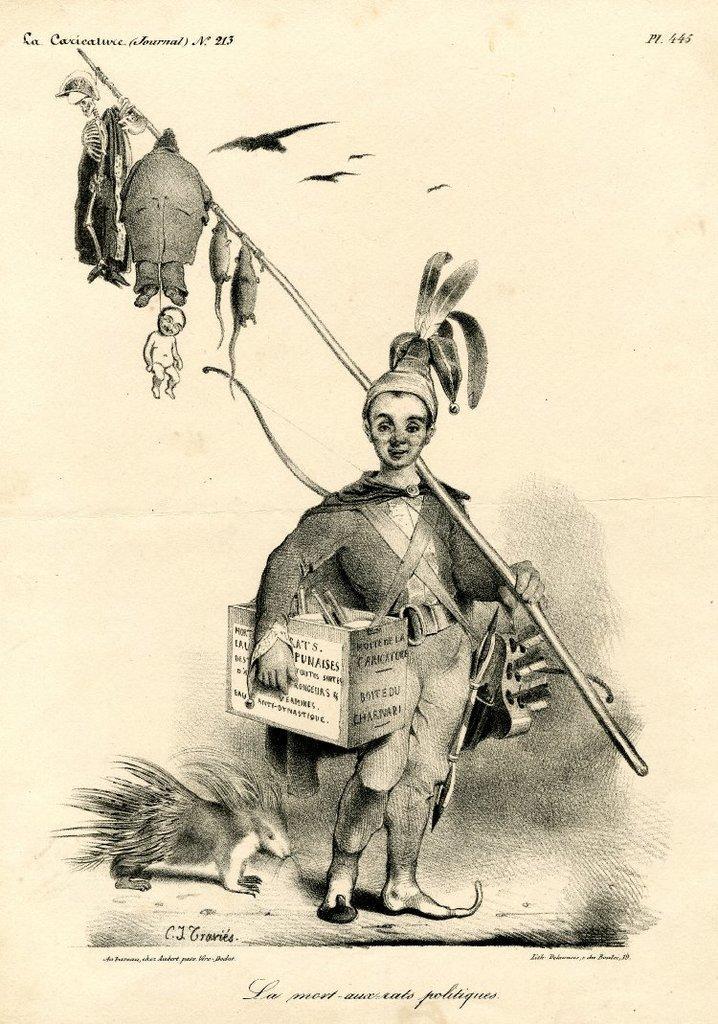In one or two sentences, can you explain what this image depicts? This is a drawing. A boy is holding a box and a stick on which a skeleton, rats and a man is hanging. There are birds flying. There is an animal at the left. 